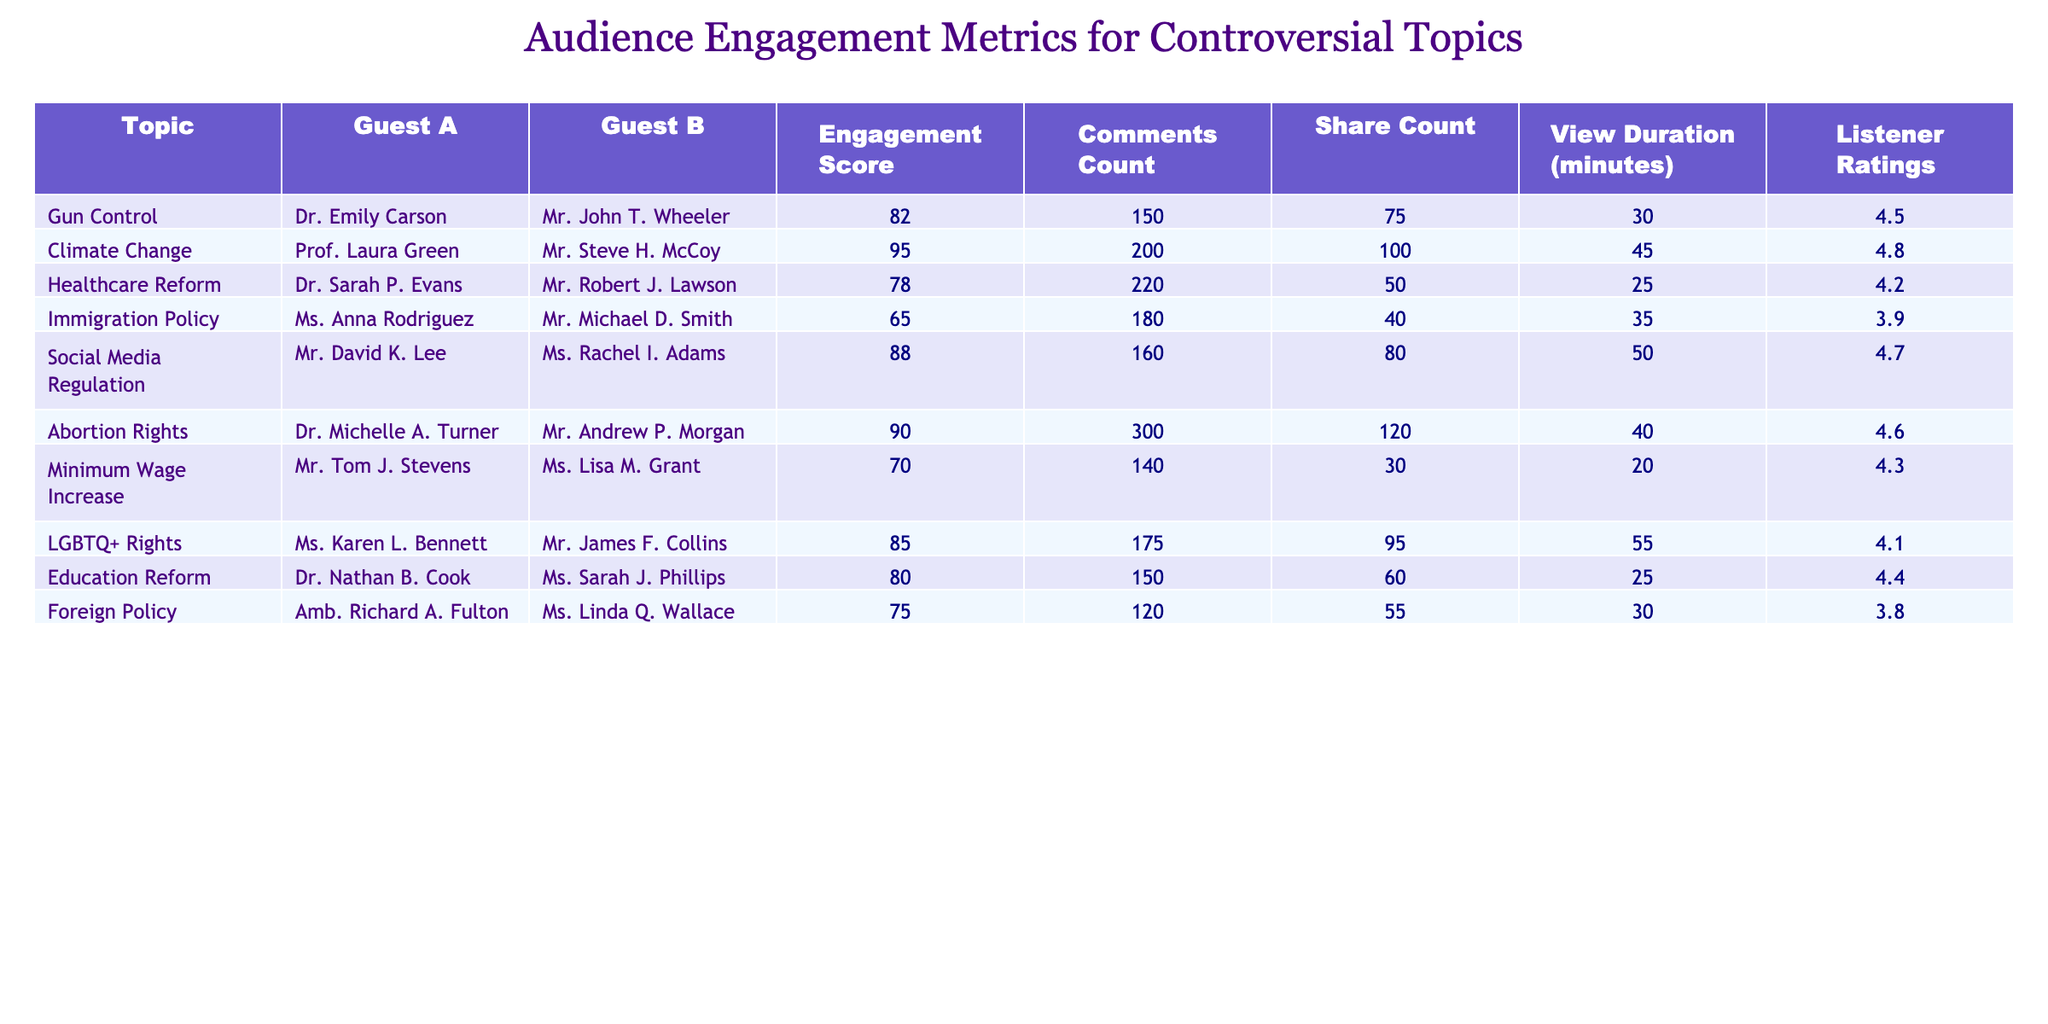What is the engagement score for the topic "Gun Control"? The engagement score for the topic "Gun Control" is directly listed in the table under the "Engagement Score" column, which shows 82.
Answer: 82 Which topic received the highest number of comments? By examining the "Comments Count" column, the topic with the highest count is "Abortion Rights" with 300 comments.
Answer: Abortion Rights What is the average engagement score of all topics? The engagement scores are 82, 95, 78, 65, 88, 90, 70, 85, 80, and 75. Adding them gives 82 + 95 + 78 + 65 + 88 + 90 + 70 + 85 + 80 + 75 =  8 scores = 81.8.
Answer: 81.8 Is the listener rating for "Immigration Policy" greater than 4? The listener rating for "Immigration Policy" is 3.9, which is less than 4; therefore, the answer is no.
Answer: No Which topic and guest combination has the most engaging share count? Reviewing the "Share Count" column, "Abortion Rights" with Dr. Michelle A. Turner has the highest share count of 120.
Answer: Abortion Rights, Dr. Michelle A. Turner What is the median view duration for the discussed topics? The view durations are 30, 45, 25, 35, 50, 40, 20, 55, 25, and 30 minutes. When ordered, they become 20, 25, 25, 30, 30, 35, 40, 45, 50, 55. The median is the average of the 5th and 6th values (30 and 35), so (30 + 35) / 2 = 32.5.
Answer: 32.5 Did "Gun Control" have more shares than "Healthcare Reform"? The share count for "Gun Control" is 75 while for "Healthcare Reform" it is 50. Since 75 is greater than 50, the answer is yes.
Answer: Yes What is the difference in comments count between "Climate Change" and "Minimum Wage Increase"? The comments count for "Climate Change" is 200, and for "Minimum Wage Increase" is 140. The difference is 200 - 140 = 60.
Answer: 60 Which guest had the smallest listener ratings, and what is that rating? The topic with the smallest listener rating is "Immigration Policy," with Mr. Michael D. Smith as the guest and a rating of 3.9.
Answer: Mr. Michael D. Smith, 3.9 